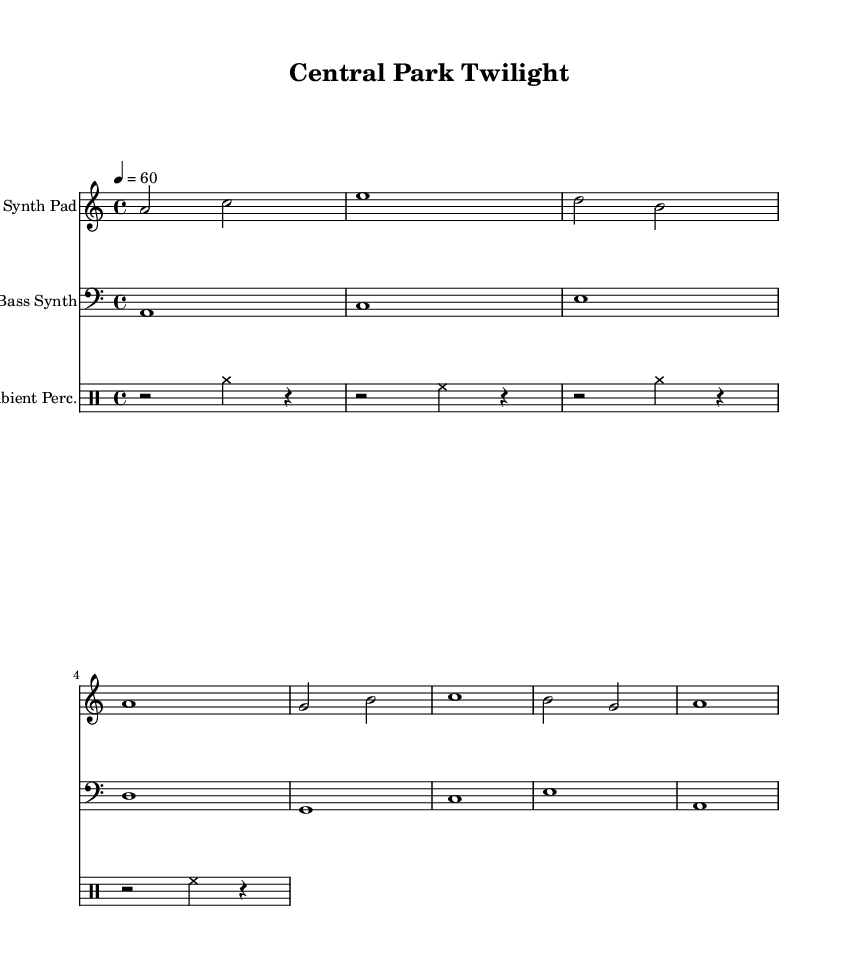What is the key signature of this music? The key signature is indicated at the start of the score with one flat, which corresponds to A minor.
Answer: A minor What is the time signature of the piece? The time signature is shown at the beginning of the score as a four over four notation, indicating each measure contains four beats.
Answer: 4/4 What is the tempo marking of the score? The tempo marking is indicated in the score by the text "4 = 60," meaning there are sixty quarter note beats per minute.
Answer: 60 How many measures are in the synth pad part? By counting the measures in the synth pad's score, there are a total of four measures written in this section.
Answer: 4 What instruments are included in this score? The score clearly lists three instruments at the top, which are the synth pad, bass synth, and ambient percussion.
Answer: Synth Pad, Bass Synth, Ambient Perc What rhythm is represented in the ambient percussion section? The ambient percussion part includes a combination of cymbals and hi-hat patterns, mostly using rapid notes and rests, with some measures featuring a solid beat while others have fewer notes.
Answer: Cymbal and Hi-Hat patterns What is the function of the bass synth in this soundscape? The bass synth is likely established to provide harmonic support along with depth to the overall sound, complementing the higher range synth pad; its foundation is key for creating a rich ambient texture.
Answer: Harmonic support and depth 